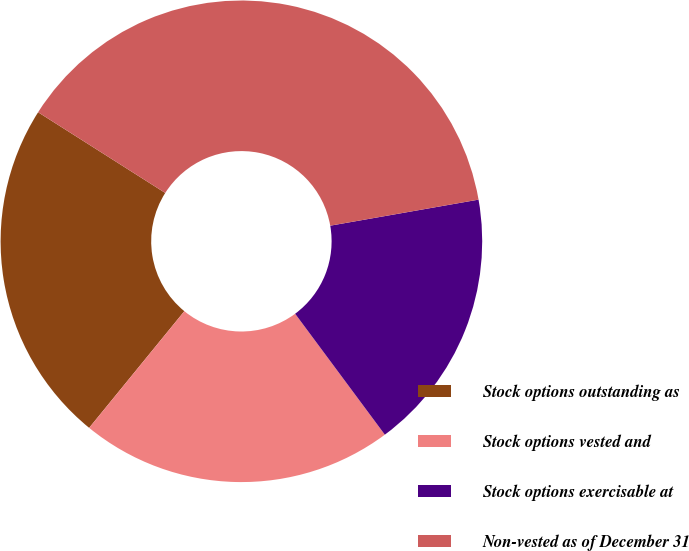Convert chart to OTSL. <chart><loc_0><loc_0><loc_500><loc_500><pie_chart><fcel>Stock options outstanding as<fcel>Stock options vested and<fcel>Stock options exercisable at<fcel>Non-vested as of December 31<nl><fcel>23.11%<fcel>21.05%<fcel>17.61%<fcel>38.23%<nl></chart> 